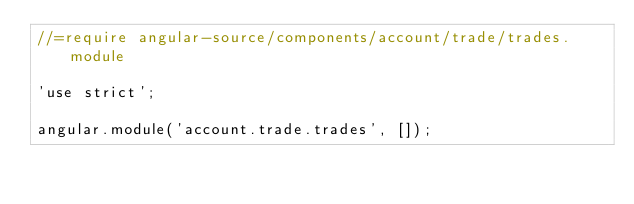Convert code to text. <code><loc_0><loc_0><loc_500><loc_500><_JavaScript_>//=require angular-source/components/account/trade/trades.module

'use strict';

angular.module('account.trade.trades', []);</code> 